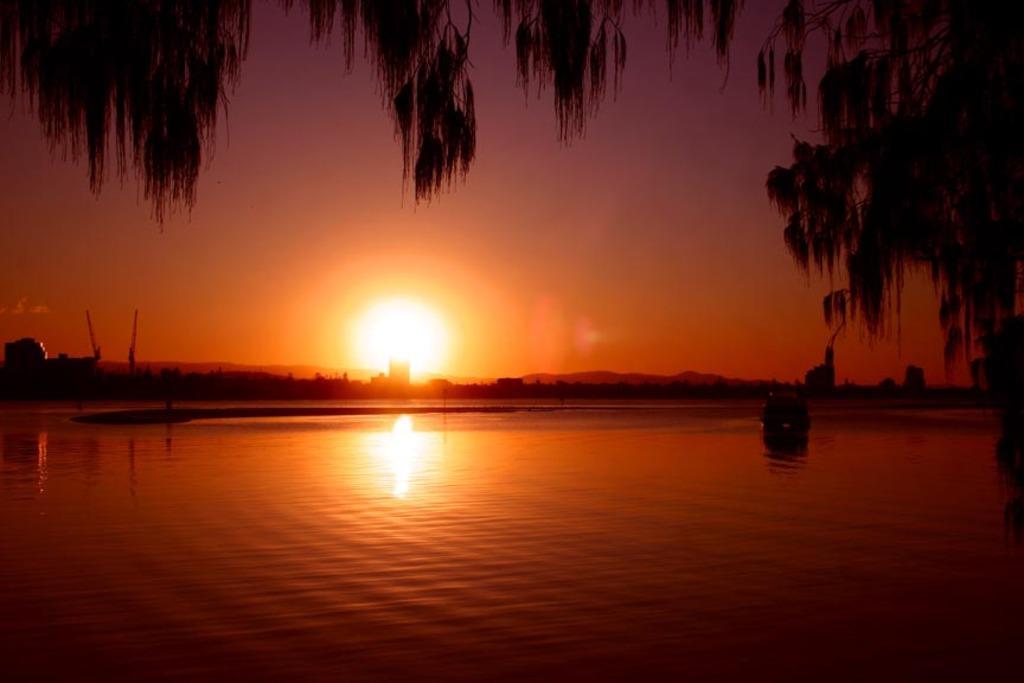Describe this image in one or two sentences. In this image there are boats in the water. There are trees, buildings, cranes, mountains. At the top of the image there is sun in the sky. 